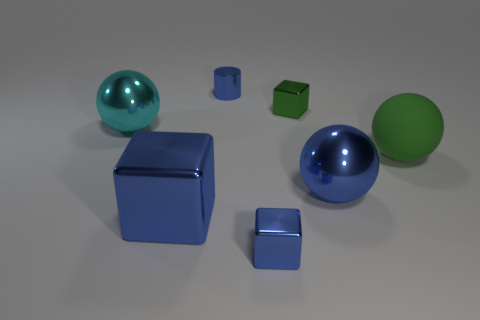Is there any other thing that is the same size as the blue metal sphere?
Ensure brevity in your answer.  Yes. There is a tiny cube that is the same color as the tiny metal cylinder; what material is it?
Ensure brevity in your answer.  Metal. Are there any other large balls that have the same color as the rubber sphere?
Ensure brevity in your answer.  No. Is there a large green matte thing that has the same shape as the cyan thing?
Make the answer very short. Yes. There is a blue thing that is behind the big cube and to the left of the big blue ball; what shape is it?
Keep it short and to the point. Cylinder. What number of big blue blocks have the same material as the big cyan ball?
Provide a short and direct response. 1. Are there fewer tiny objects that are in front of the big green matte ball than tiny metal blocks?
Keep it short and to the point. Yes. Is there a cyan ball behind the tiny object that is behind the small green metal thing?
Provide a succinct answer. No. Is the size of the cyan metal object the same as the green matte thing?
Offer a very short reply. Yes. What material is the green thing that is on the right side of the shiny cube right of the tiny metal cube in front of the big matte sphere?
Give a very brief answer. Rubber. 